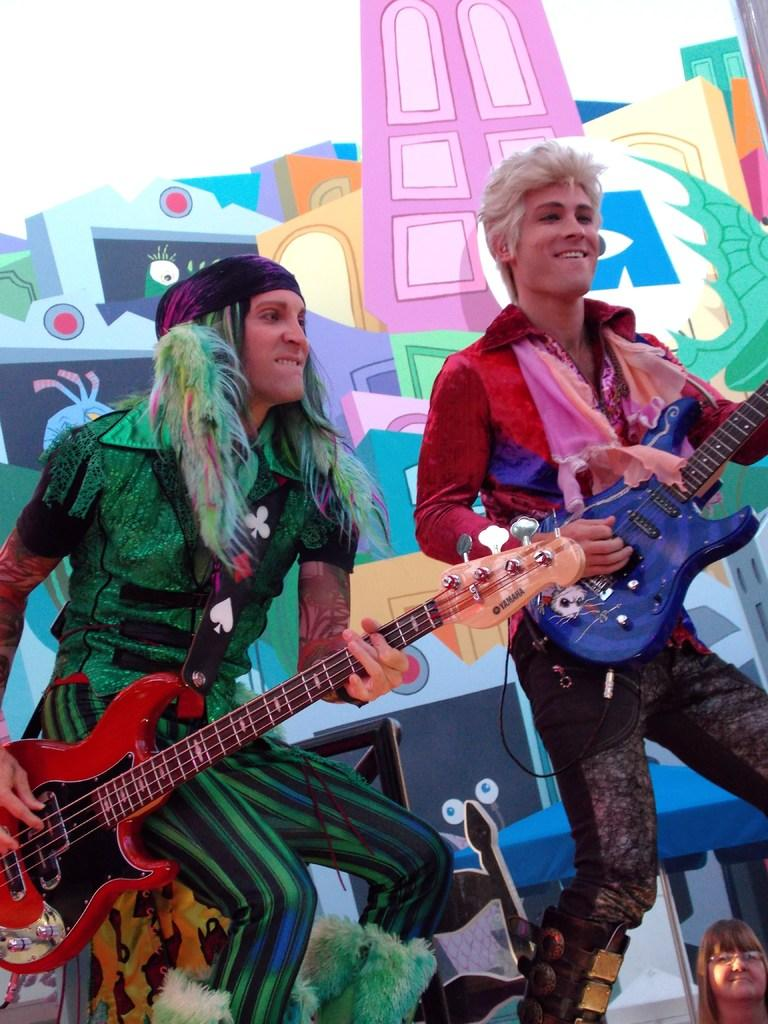How many people are in the image? There are two persons in the image. What are the two persons doing in the image? The two persons are playing the guitar. What can be seen in the background of the image? There is an animation in the background of the image. What is the income of the person playing the guitar in the image? There is no information about the income of the person playing the guitar in the image. 